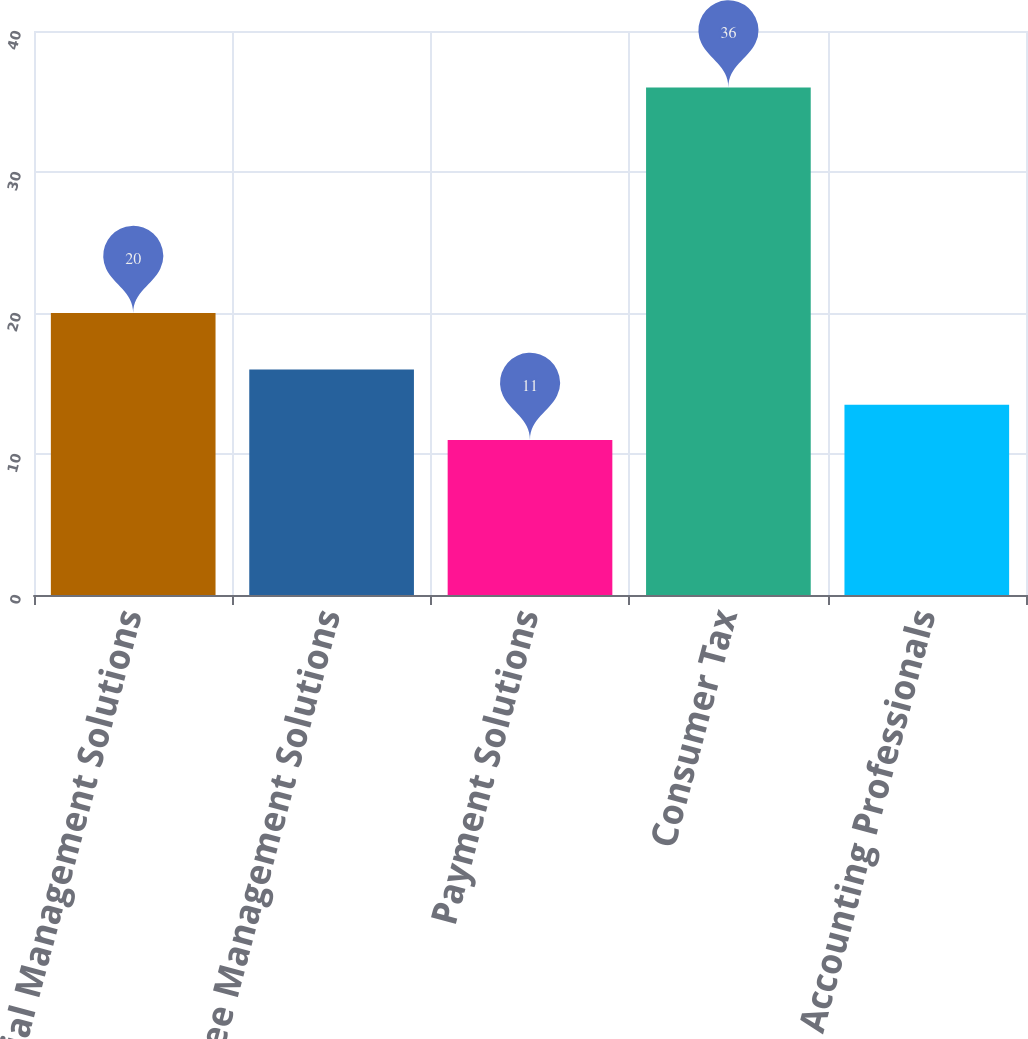Convert chart. <chart><loc_0><loc_0><loc_500><loc_500><bar_chart><fcel>Financial Management Solutions<fcel>Employee Management Solutions<fcel>Payment Solutions<fcel>Consumer Tax<fcel>Accounting Professionals<nl><fcel>20<fcel>16<fcel>11<fcel>36<fcel>13.5<nl></chart> 